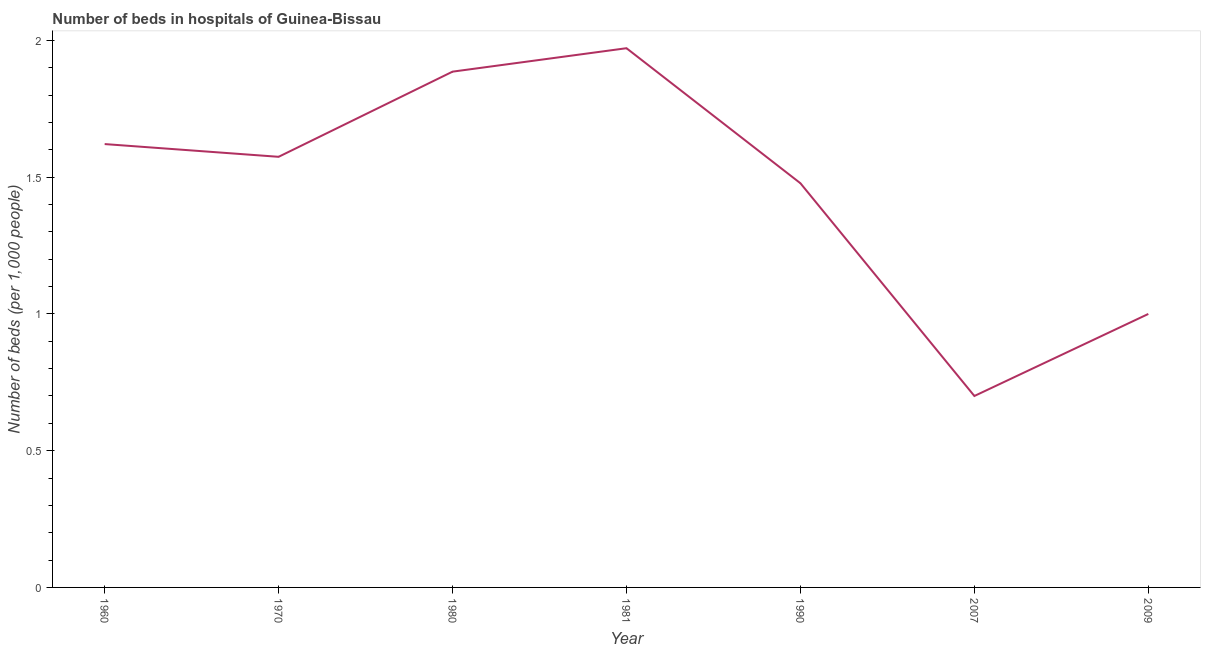What is the number of hospital beds in 1970?
Give a very brief answer. 1.57. Across all years, what is the maximum number of hospital beds?
Make the answer very short. 1.97. Across all years, what is the minimum number of hospital beds?
Your answer should be very brief. 0.7. In which year was the number of hospital beds maximum?
Your answer should be compact. 1981. In which year was the number of hospital beds minimum?
Keep it short and to the point. 2007. What is the sum of the number of hospital beds?
Keep it short and to the point. 10.23. What is the difference between the number of hospital beds in 1960 and 1970?
Make the answer very short. 0.05. What is the average number of hospital beds per year?
Give a very brief answer. 1.46. What is the median number of hospital beds?
Give a very brief answer. 1.57. In how many years, is the number of hospital beds greater than 0.9 %?
Keep it short and to the point. 6. Do a majority of the years between 2009 and 1970 (inclusive) have number of hospital beds greater than 1.8 %?
Give a very brief answer. Yes. What is the ratio of the number of hospital beds in 1970 to that in 2007?
Your answer should be very brief. 2.25. Is the difference between the number of hospital beds in 1960 and 1990 greater than the difference between any two years?
Make the answer very short. No. What is the difference between the highest and the second highest number of hospital beds?
Provide a short and direct response. 0.09. What is the difference between the highest and the lowest number of hospital beds?
Provide a short and direct response. 1.27. In how many years, is the number of hospital beds greater than the average number of hospital beds taken over all years?
Give a very brief answer. 5. How many years are there in the graph?
Give a very brief answer. 7. Are the values on the major ticks of Y-axis written in scientific E-notation?
Provide a succinct answer. No. What is the title of the graph?
Ensure brevity in your answer.  Number of beds in hospitals of Guinea-Bissau. What is the label or title of the X-axis?
Your response must be concise. Year. What is the label or title of the Y-axis?
Provide a succinct answer. Number of beds (per 1,0 people). What is the Number of beds (per 1,000 people) of 1960?
Your answer should be very brief. 1.62. What is the Number of beds (per 1,000 people) of 1970?
Make the answer very short. 1.57. What is the Number of beds (per 1,000 people) in 1980?
Ensure brevity in your answer.  1.89. What is the Number of beds (per 1,000 people) in 1981?
Make the answer very short. 1.97. What is the Number of beds (per 1,000 people) in 1990?
Provide a succinct answer. 1.48. What is the Number of beds (per 1,000 people) in 2009?
Your answer should be compact. 1. What is the difference between the Number of beds (per 1,000 people) in 1960 and 1970?
Provide a succinct answer. 0.05. What is the difference between the Number of beds (per 1,000 people) in 1960 and 1980?
Offer a terse response. -0.26. What is the difference between the Number of beds (per 1,000 people) in 1960 and 1981?
Offer a very short reply. -0.35. What is the difference between the Number of beds (per 1,000 people) in 1960 and 1990?
Give a very brief answer. 0.14. What is the difference between the Number of beds (per 1,000 people) in 1960 and 2007?
Offer a very short reply. 0.92. What is the difference between the Number of beds (per 1,000 people) in 1960 and 2009?
Keep it short and to the point. 0.62. What is the difference between the Number of beds (per 1,000 people) in 1970 and 1980?
Offer a very short reply. -0.31. What is the difference between the Number of beds (per 1,000 people) in 1970 and 1981?
Give a very brief answer. -0.4. What is the difference between the Number of beds (per 1,000 people) in 1970 and 1990?
Give a very brief answer. 0.1. What is the difference between the Number of beds (per 1,000 people) in 1970 and 2007?
Give a very brief answer. 0.87. What is the difference between the Number of beds (per 1,000 people) in 1970 and 2009?
Provide a short and direct response. 0.57. What is the difference between the Number of beds (per 1,000 people) in 1980 and 1981?
Keep it short and to the point. -0.09. What is the difference between the Number of beds (per 1,000 people) in 1980 and 1990?
Your answer should be compact. 0.41. What is the difference between the Number of beds (per 1,000 people) in 1980 and 2007?
Provide a succinct answer. 1.19. What is the difference between the Number of beds (per 1,000 people) in 1980 and 2009?
Your answer should be compact. 0.89. What is the difference between the Number of beds (per 1,000 people) in 1981 and 1990?
Your answer should be compact. 0.49. What is the difference between the Number of beds (per 1,000 people) in 1981 and 2007?
Your answer should be compact. 1.27. What is the difference between the Number of beds (per 1,000 people) in 1981 and 2009?
Make the answer very short. 0.97. What is the difference between the Number of beds (per 1,000 people) in 1990 and 2007?
Your answer should be compact. 0.78. What is the difference between the Number of beds (per 1,000 people) in 1990 and 2009?
Provide a succinct answer. 0.48. What is the ratio of the Number of beds (per 1,000 people) in 1960 to that in 1970?
Give a very brief answer. 1.03. What is the ratio of the Number of beds (per 1,000 people) in 1960 to that in 1980?
Your answer should be compact. 0.86. What is the ratio of the Number of beds (per 1,000 people) in 1960 to that in 1981?
Offer a terse response. 0.82. What is the ratio of the Number of beds (per 1,000 people) in 1960 to that in 1990?
Provide a short and direct response. 1.1. What is the ratio of the Number of beds (per 1,000 people) in 1960 to that in 2007?
Your answer should be compact. 2.32. What is the ratio of the Number of beds (per 1,000 people) in 1960 to that in 2009?
Your answer should be compact. 1.62. What is the ratio of the Number of beds (per 1,000 people) in 1970 to that in 1980?
Make the answer very short. 0.83. What is the ratio of the Number of beds (per 1,000 people) in 1970 to that in 1981?
Provide a succinct answer. 0.8. What is the ratio of the Number of beds (per 1,000 people) in 1970 to that in 1990?
Provide a succinct answer. 1.06. What is the ratio of the Number of beds (per 1,000 people) in 1970 to that in 2007?
Your response must be concise. 2.25. What is the ratio of the Number of beds (per 1,000 people) in 1970 to that in 2009?
Your answer should be very brief. 1.57. What is the ratio of the Number of beds (per 1,000 people) in 1980 to that in 1981?
Ensure brevity in your answer.  0.96. What is the ratio of the Number of beds (per 1,000 people) in 1980 to that in 1990?
Make the answer very short. 1.28. What is the ratio of the Number of beds (per 1,000 people) in 1980 to that in 2007?
Keep it short and to the point. 2.69. What is the ratio of the Number of beds (per 1,000 people) in 1980 to that in 2009?
Make the answer very short. 1.89. What is the ratio of the Number of beds (per 1,000 people) in 1981 to that in 1990?
Keep it short and to the point. 1.33. What is the ratio of the Number of beds (per 1,000 people) in 1981 to that in 2007?
Provide a short and direct response. 2.82. What is the ratio of the Number of beds (per 1,000 people) in 1981 to that in 2009?
Your answer should be compact. 1.97. What is the ratio of the Number of beds (per 1,000 people) in 1990 to that in 2007?
Offer a terse response. 2.11. What is the ratio of the Number of beds (per 1,000 people) in 1990 to that in 2009?
Ensure brevity in your answer.  1.48. What is the ratio of the Number of beds (per 1,000 people) in 2007 to that in 2009?
Offer a terse response. 0.7. 